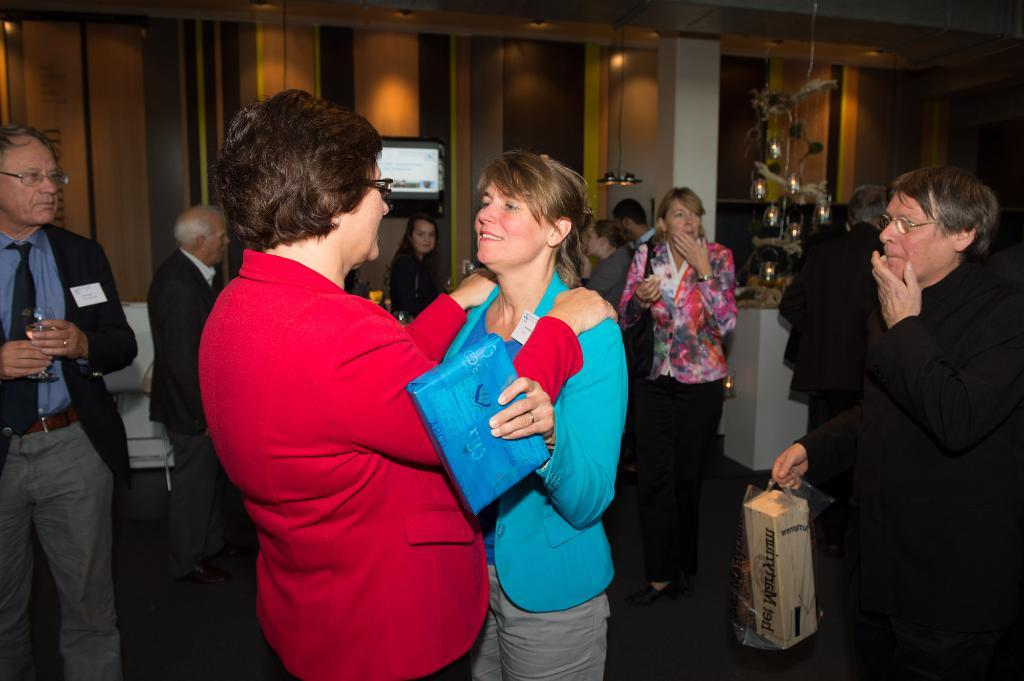Who or what can be seen in the image? There are people in the image. What is on the wall in the background of the image? There is a board on the wall in the background of the image. What can be seen at the top of the image? There are lights visible at the top of the image. What type of wound can be seen on the person in the image? There is no wound visible on any person in the image. What is the temper of the person in the image? There is no indication of the temper of any person in the image. 